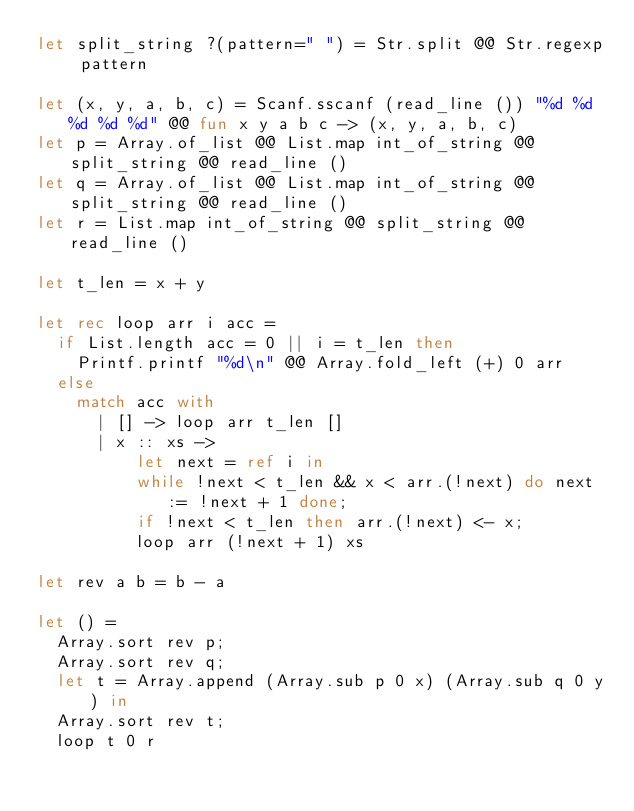<code> <loc_0><loc_0><loc_500><loc_500><_OCaml_>let split_string ?(pattern=" ") = Str.split @@ Str.regexp pattern

let (x, y, a, b, c) = Scanf.sscanf (read_line ()) "%d %d %d %d %d" @@ fun x y a b c -> (x, y, a, b, c)
let p = Array.of_list @@ List.map int_of_string @@ split_string @@ read_line ()
let q = Array.of_list @@ List.map int_of_string @@ split_string @@ read_line ()
let r = List.map int_of_string @@ split_string @@ read_line ()

let t_len = x + y

let rec loop arr i acc = 
  if List.length acc = 0 || i = t_len then
    Printf.printf "%d\n" @@ Array.fold_left (+) 0 arr
  else
    match acc with
      | [] -> loop arr t_len []
      | x :: xs ->
          let next = ref i in
          while !next < t_len && x < arr.(!next) do next := !next + 1 done;
          if !next < t_len then arr.(!next) <- x;
          loop arr (!next + 1) xs

let rev a b = b - a

let () =
  Array.sort rev p;
  Array.sort rev q;
  let t = Array.append (Array.sub p 0 x) (Array.sub q 0 y) in
  Array.sort rev t;
  loop t 0 r</code> 